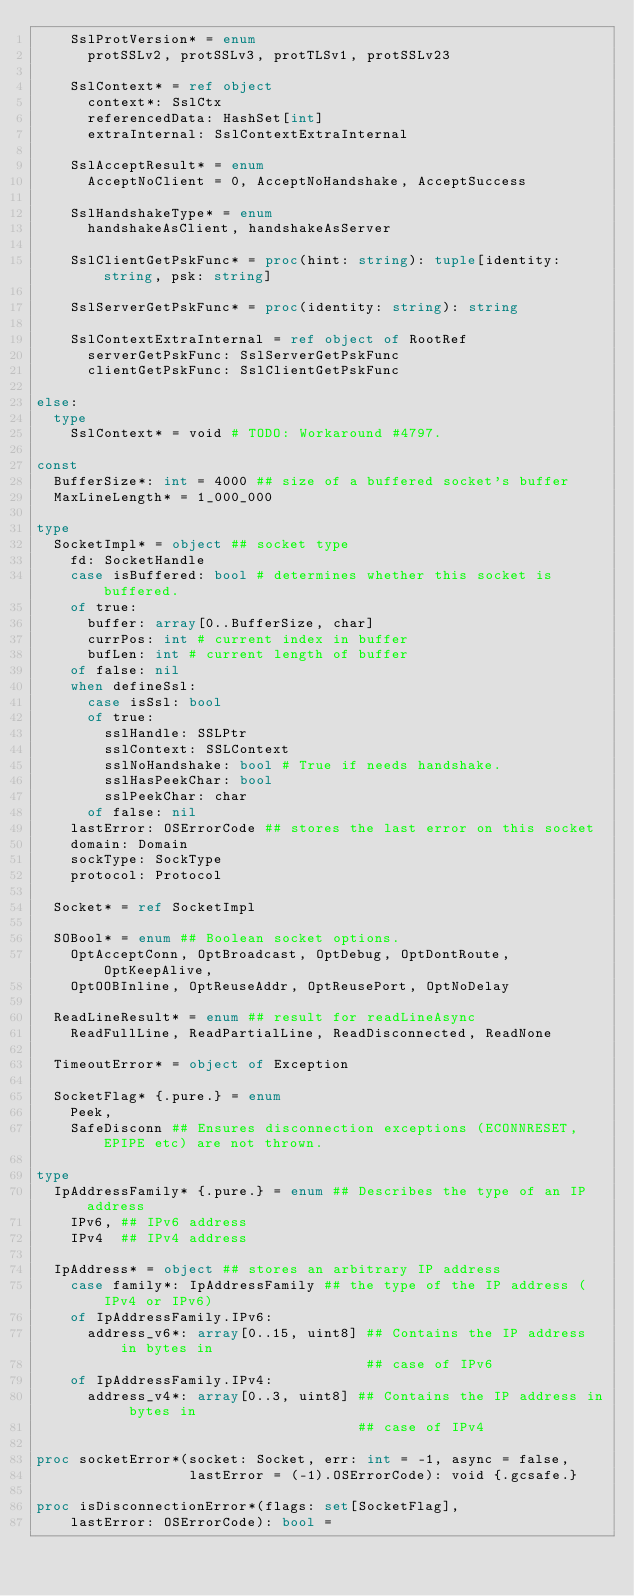Convert code to text. <code><loc_0><loc_0><loc_500><loc_500><_Nim_>    SslProtVersion* = enum
      protSSLv2, protSSLv3, protTLSv1, protSSLv23

    SslContext* = ref object
      context*: SslCtx
      referencedData: HashSet[int]
      extraInternal: SslContextExtraInternal

    SslAcceptResult* = enum
      AcceptNoClient = 0, AcceptNoHandshake, AcceptSuccess

    SslHandshakeType* = enum
      handshakeAsClient, handshakeAsServer

    SslClientGetPskFunc* = proc(hint: string): tuple[identity: string, psk: string]

    SslServerGetPskFunc* = proc(identity: string): string

    SslContextExtraInternal = ref object of RootRef
      serverGetPskFunc: SslServerGetPskFunc
      clientGetPskFunc: SslClientGetPskFunc

else:
  type
    SslContext* = void # TODO: Workaround #4797.

const
  BufferSize*: int = 4000 ## size of a buffered socket's buffer
  MaxLineLength* = 1_000_000

type
  SocketImpl* = object ## socket type
    fd: SocketHandle
    case isBuffered: bool # determines whether this socket is buffered.
    of true:
      buffer: array[0..BufferSize, char]
      currPos: int # current index in buffer
      bufLen: int # current length of buffer
    of false: nil
    when defineSsl:
      case isSsl: bool
      of true:
        sslHandle: SSLPtr
        sslContext: SSLContext
        sslNoHandshake: bool # True if needs handshake.
        sslHasPeekChar: bool
        sslPeekChar: char
      of false: nil
    lastError: OSErrorCode ## stores the last error on this socket
    domain: Domain
    sockType: SockType
    protocol: Protocol

  Socket* = ref SocketImpl

  SOBool* = enum ## Boolean socket options.
    OptAcceptConn, OptBroadcast, OptDebug, OptDontRoute, OptKeepAlive,
    OptOOBInline, OptReuseAddr, OptReusePort, OptNoDelay

  ReadLineResult* = enum ## result for readLineAsync
    ReadFullLine, ReadPartialLine, ReadDisconnected, ReadNone

  TimeoutError* = object of Exception

  SocketFlag* {.pure.} = enum
    Peek,
    SafeDisconn ## Ensures disconnection exceptions (ECONNRESET, EPIPE etc) are not thrown.

type
  IpAddressFamily* {.pure.} = enum ## Describes the type of an IP address
    IPv6, ## IPv6 address
    IPv4  ## IPv4 address

  IpAddress* = object ## stores an arbitrary IP address
    case family*: IpAddressFamily ## the type of the IP address (IPv4 or IPv6)
    of IpAddressFamily.IPv6:
      address_v6*: array[0..15, uint8] ## Contains the IP address in bytes in
                                       ## case of IPv6
    of IpAddressFamily.IPv4:
      address_v4*: array[0..3, uint8] ## Contains the IP address in bytes in
                                      ## case of IPv4

proc socketError*(socket: Socket, err: int = -1, async = false,
                  lastError = (-1).OSErrorCode): void {.gcsafe.}

proc isDisconnectionError*(flags: set[SocketFlag],
    lastError: OSErrorCode): bool =</code> 